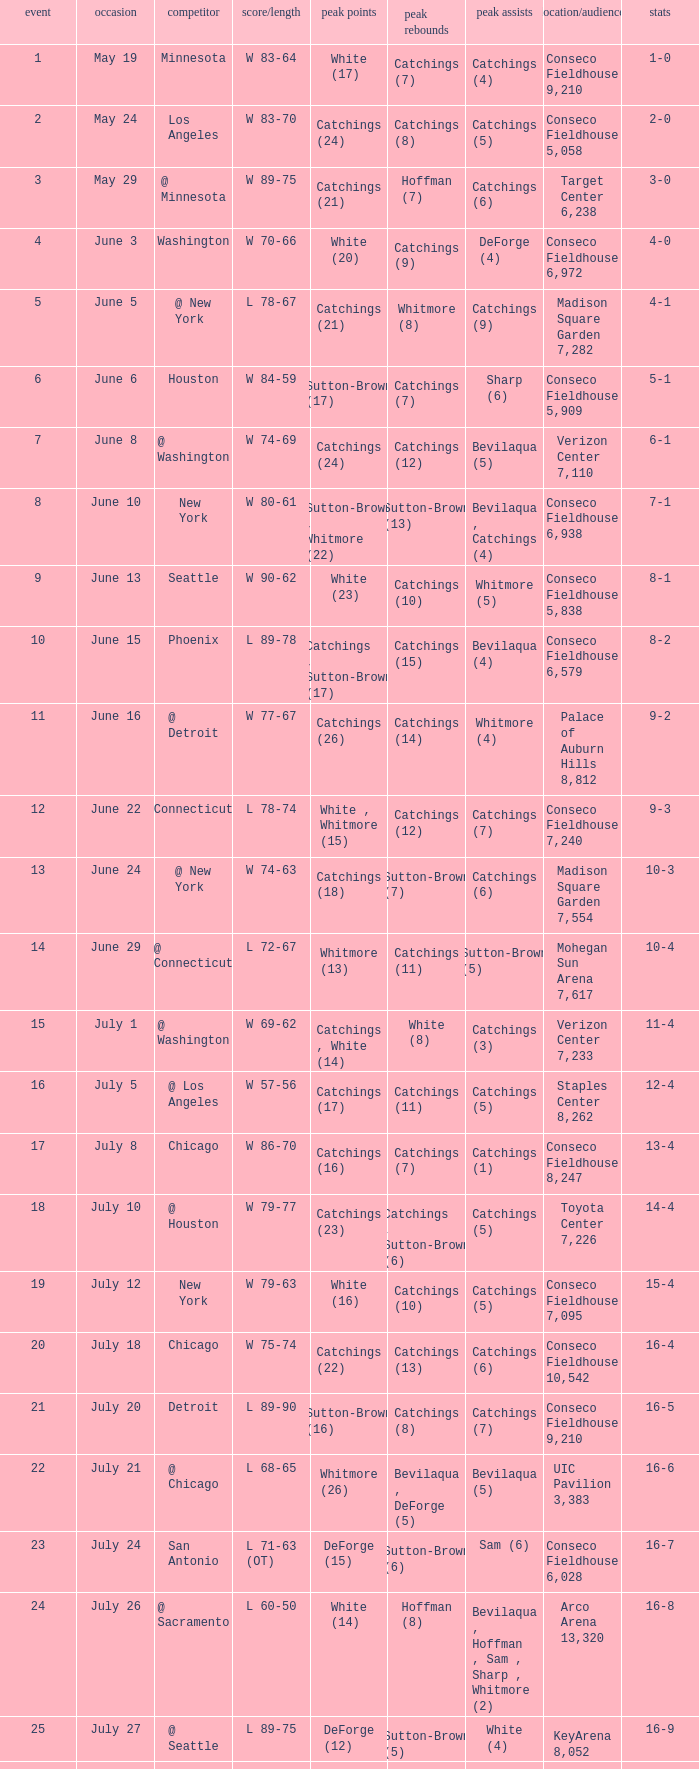Name the date where score time is w 74-63 June 24. 